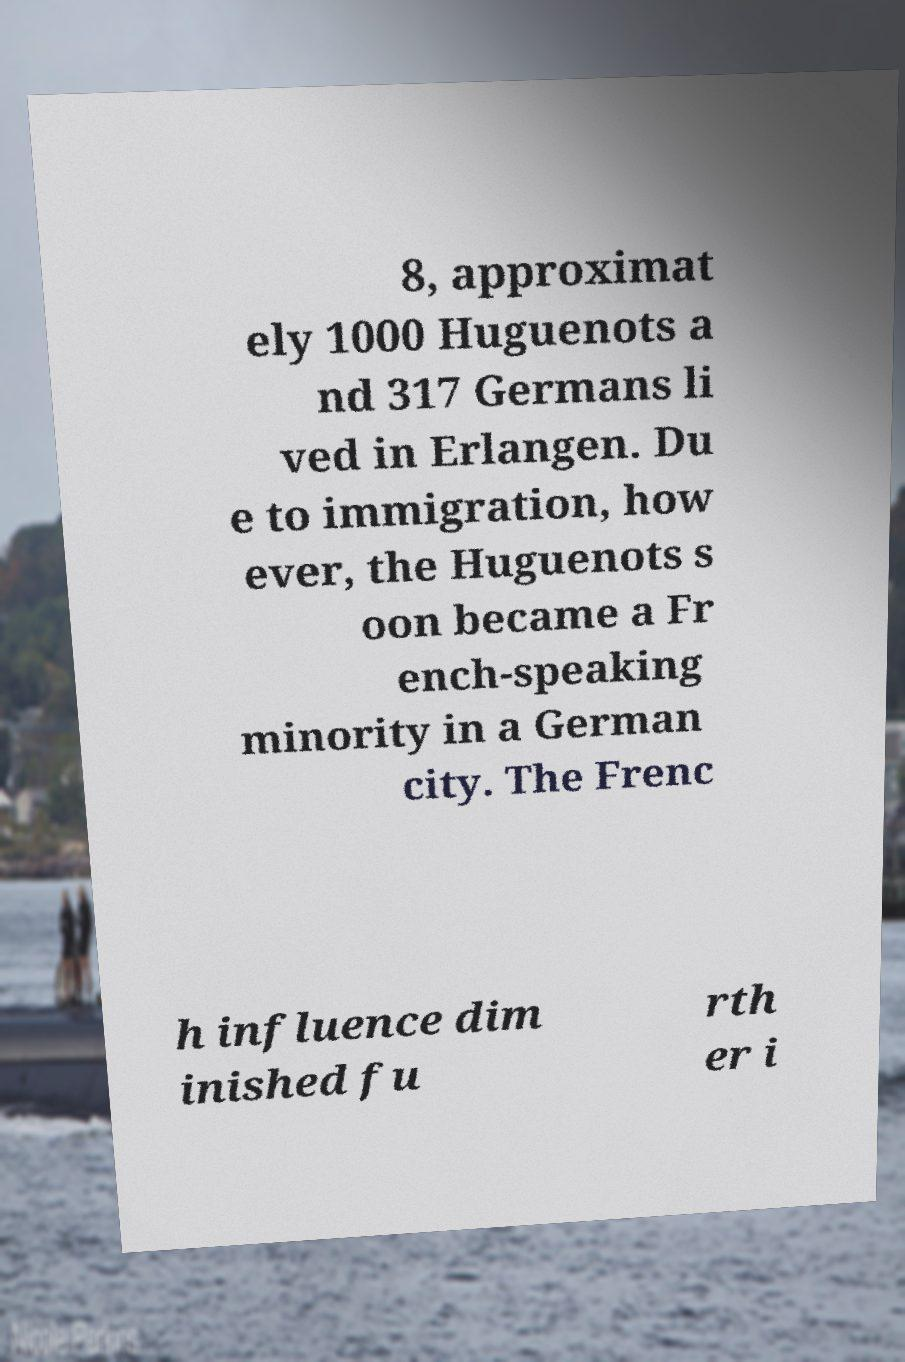There's text embedded in this image that I need extracted. Can you transcribe it verbatim? 8, approximat ely 1000 Huguenots a nd 317 Germans li ved in Erlangen. Du e to immigration, how ever, the Huguenots s oon became a Fr ench-speaking minority in a German city. The Frenc h influence dim inished fu rth er i 